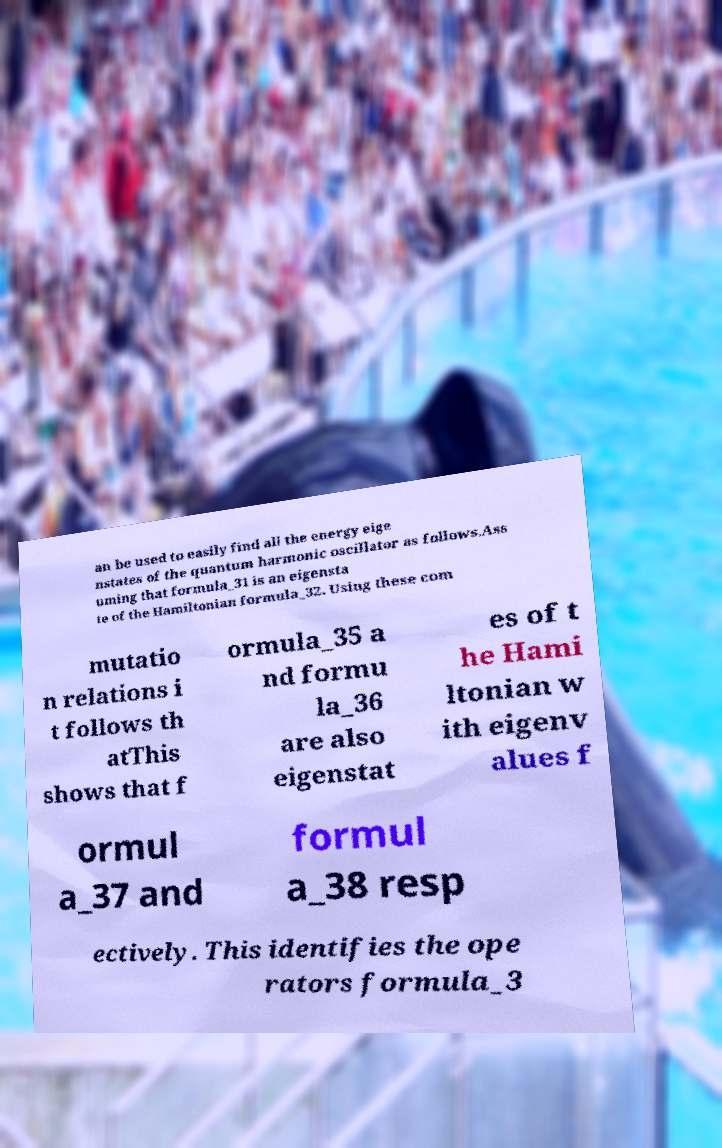Please read and relay the text visible in this image. What does it say? an be used to easily find all the energy eige nstates of the quantum harmonic oscillator as follows.Ass uming that formula_31 is an eigensta te of the Hamiltonian formula_32. Using these com mutatio n relations i t follows th atThis shows that f ormula_35 a nd formu la_36 are also eigenstat es of t he Hami ltonian w ith eigenv alues f ormul a_37 and formul a_38 resp ectively. This identifies the ope rators formula_3 